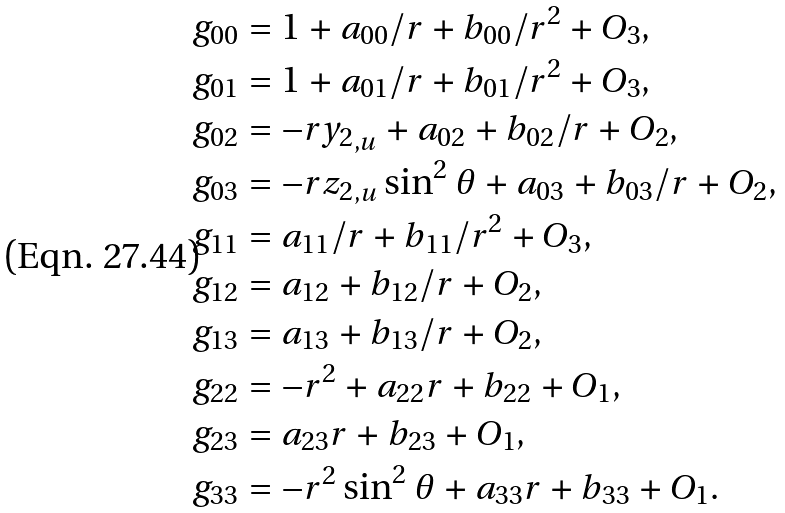Convert formula to latex. <formula><loc_0><loc_0><loc_500><loc_500>g _ { 0 0 } & = 1 + a _ { 0 0 } / r + b _ { 0 0 } / r ^ { 2 } + O _ { 3 } , \\ g _ { 0 1 } & = 1 + a _ { 0 1 } / r + b _ { 0 1 } / r ^ { 2 } + O _ { 3 } , \\ g _ { 0 2 } & = - r { y _ { 2 } } _ { , u } + a _ { 0 2 } + b _ { 0 2 } / r + O _ { 2 } , \\ g _ { 0 3 } & = - r { z _ { 2 } } _ { , u } \sin ^ { 2 } \theta + a _ { 0 3 } + b _ { 0 3 } / r + O _ { 2 } , \\ g _ { 1 1 } & = a _ { 1 1 } / r + b _ { 1 1 } / r ^ { 2 } + O _ { 3 } , \\ g _ { 1 2 } & = a _ { 1 2 } + b _ { 1 2 } / r + O _ { 2 } , \\ g _ { 1 3 } & = a _ { 1 3 } + b _ { 1 3 } / r + O _ { 2 } , \\ g _ { 2 2 } & = - r ^ { 2 } + a _ { 2 2 } r + b _ { 2 2 } + O _ { 1 } , \\ g _ { 2 3 } & = a _ { 2 3 } r + b _ { 2 3 } + O _ { 1 } , \\ g _ { 3 3 } & = - r ^ { 2 } \sin ^ { 2 } \theta + a _ { 3 3 } r + b _ { 3 3 } + O _ { 1 } . \\</formula> 